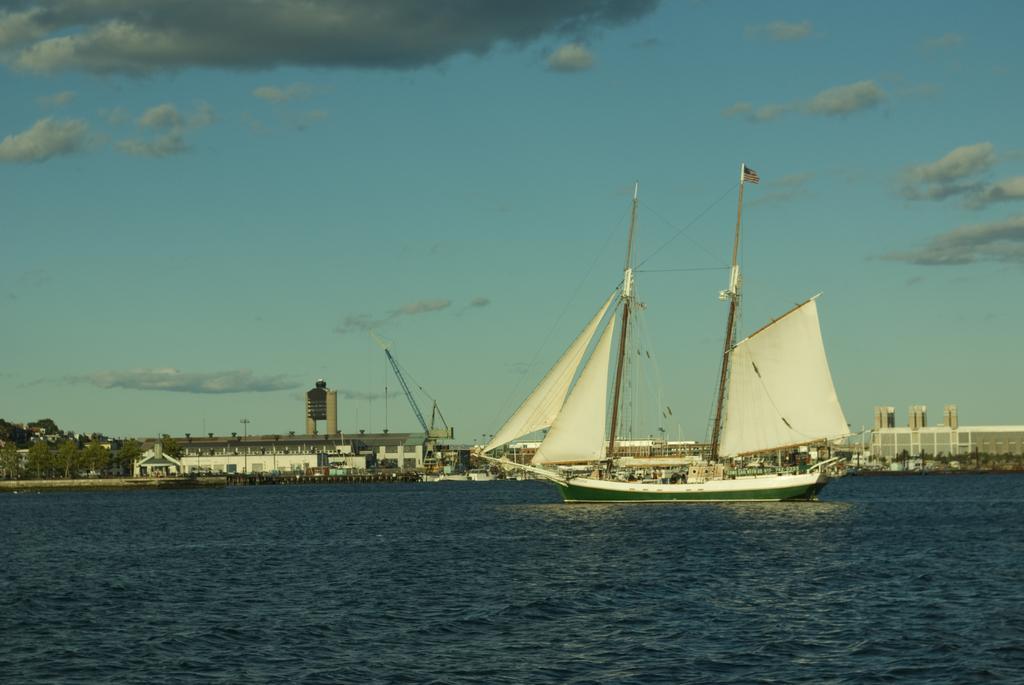Could you give a brief overview of what you see in this image? In the background we can see the clouds in the sky. In this picture we can see the boat, sail cloths, crane, poles, water, trees and the buildings. 